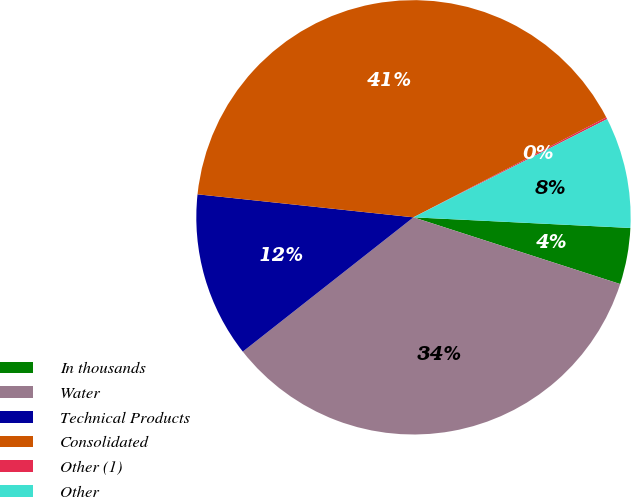Convert chart. <chart><loc_0><loc_0><loc_500><loc_500><pie_chart><fcel>In thousands<fcel>Water<fcel>Technical Products<fcel>Consolidated<fcel>Other (1)<fcel>Other<nl><fcel>4.19%<fcel>34.42%<fcel>12.3%<fcel>40.7%<fcel>0.14%<fcel>8.25%<nl></chart> 